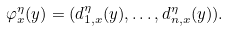Convert formula to latex. <formula><loc_0><loc_0><loc_500><loc_500>\varphi _ { x } ^ { \eta } ( y ) = ( d _ { 1 , x } ^ { \eta } ( y ) , \dots , d _ { n , x } ^ { \eta } ( y ) ) .</formula> 